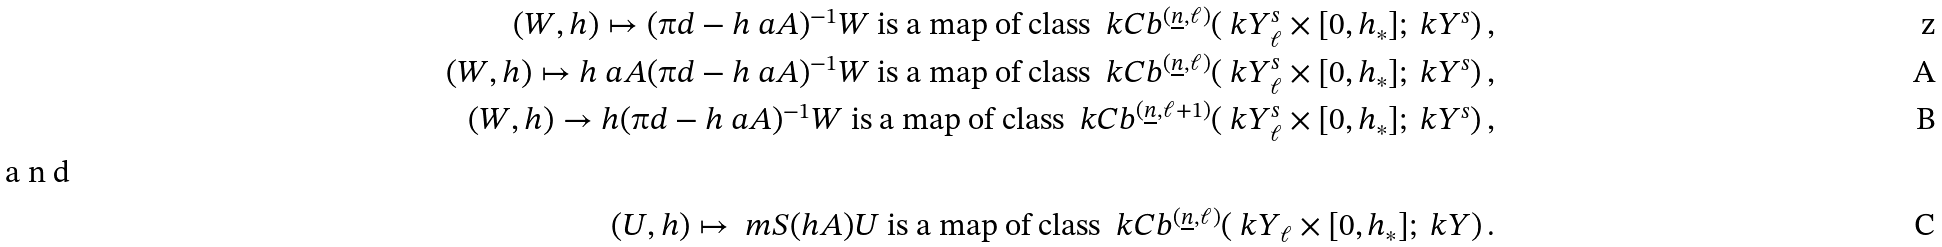<formula> <loc_0><loc_0><loc_500><loc_500>( W , h ) \mapsto ( \i d - h \ a A ) ^ { - 1 } W \text { is a map of class } \ k C b ^ { ( \underline { n } , \ell ) } ( \ k Y ^ { s } _ { \ell } \times [ 0 , h _ { * } ] ; \ k Y ^ { s } ) \, , \\ ( W , h ) \mapsto h \ a A ( \i d - h \ a A ) ^ { - 1 } W \text { is a map of class } \ k C b ^ { ( \underline { n } , \ell ) } ( \ k Y ^ { s } _ { \ell } \times [ 0 , h _ { * } ] ; \ k Y ^ { s } ) \, , \\ ( W , h ) \to h ( \i d - h \ a A ) ^ { - 1 } W \text { is a map of class } \ k C b ^ { ( \underline { n } , \ell + 1 ) } ( \ k Y ^ { s } _ { \ell } \times [ 0 , h _ { * } ] ; \ k Y ^ { s } ) \, , \\ \intertext { a n d } ( U , h ) \mapsto \ m S ( h A ) U \text { is a map of class } \ k C b ^ { ( \underline { n } , \ell ) } ( \ k Y _ { \ell } \times [ 0 , h _ { * } ] ; \ k Y ) \, .</formula> 